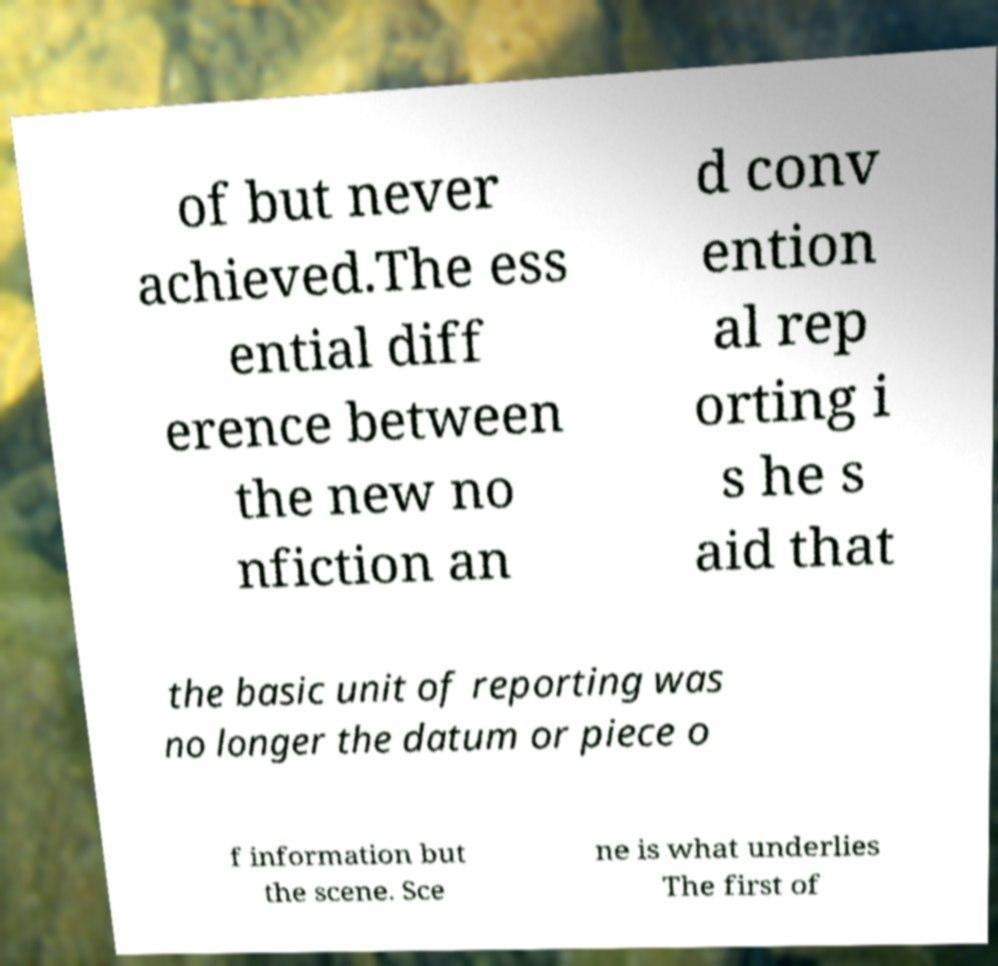Please read and relay the text visible in this image. What does it say? of but never achieved.The ess ential diff erence between the new no nfiction an d conv ention al rep orting i s he s aid that the basic unit of reporting was no longer the datum or piece o f information but the scene. Sce ne is what underlies The first of 